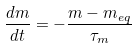<formula> <loc_0><loc_0><loc_500><loc_500>\frac { d m } { d t } = - \frac { m - m _ { e q } } { \tau _ { m } }</formula> 